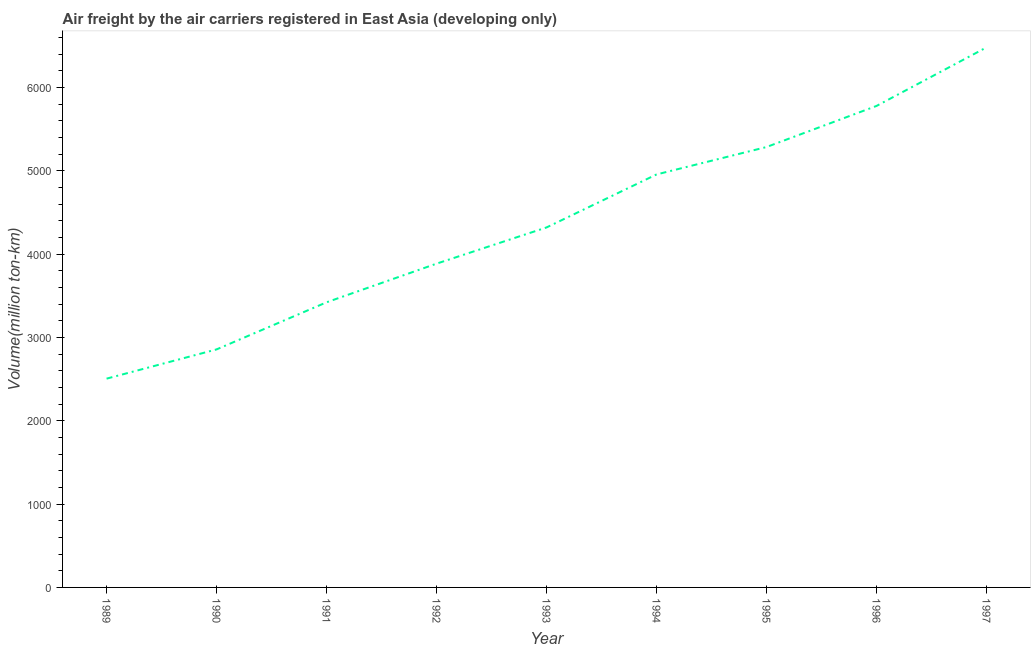What is the air freight in 1995?
Make the answer very short. 5285.2. Across all years, what is the maximum air freight?
Keep it short and to the point. 6480.9. Across all years, what is the minimum air freight?
Offer a very short reply. 2505.5. In which year was the air freight maximum?
Give a very brief answer. 1997. What is the sum of the air freight?
Keep it short and to the point. 3.95e+04. What is the difference between the air freight in 1989 and 1995?
Your answer should be compact. -2779.7. What is the average air freight per year?
Offer a very short reply. 4387.73. What is the median air freight?
Your response must be concise. 4320. Do a majority of the years between 1993 and 1992 (inclusive) have air freight greater than 800 million ton-km?
Provide a succinct answer. No. What is the ratio of the air freight in 1991 to that in 1997?
Your response must be concise. 0.53. Is the air freight in 1989 less than that in 1993?
Ensure brevity in your answer.  Yes. What is the difference between the highest and the second highest air freight?
Provide a short and direct response. 702.7. Is the sum of the air freight in 1990 and 1993 greater than the maximum air freight across all years?
Provide a succinct answer. Yes. What is the difference between the highest and the lowest air freight?
Your answer should be compact. 3975.4. In how many years, is the air freight greater than the average air freight taken over all years?
Your answer should be compact. 4. How many years are there in the graph?
Offer a terse response. 9. What is the difference between two consecutive major ticks on the Y-axis?
Your answer should be compact. 1000. Does the graph contain any zero values?
Keep it short and to the point. No. What is the title of the graph?
Your response must be concise. Air freight by the air carriers registered in East Asia (developing only). What is the label or title of the Y-axis?
Ensure brevity in your answer.  Volume(million ton-km). What is the Volume(million ton-km) of 1989?
Keep it short and to the point. 2505.5. What is the Volume(million ton-km) of 1990?
Make the answer very short. 2856.4. What is the Volume(million ton-km) of 1991?
Make the answer very short. 3421.8. What is the Volume(million ton-km) of 1992?
Give a very brief answer. 3885.5. What is the Volume(million ton-km) in 1993?
Offer a terse response. 4320. What is the Volume(million ton-km) of 1994?
Offer a very short reply. 4956.1. What is the Volume(million ton-km) in 1995?
Give a very brief answer. 5285.2. What is the Volume(million ton-km) in 1996?
Give a very brief answer. 5778.2. What is the Volume(million ton-km) of 1997?
Keep it short and to the point. 6480.9. What is the difference between the Volume(million ton-km) in 1989 and 1990?
Keep it short and to the point. -350.9. What is the difference between the Volume(million ton-km) in 1989 and 1991?
Give a very brief answer. -916.3. What is the difference between the Volume(million ton-km) in 1989 and 1992?
Provide a short and direct response. -1380. What is the difference between the Volume(million ton-km) in 1989 and 1993?
Provide a succinct answer. -1814.5. What is the difference between the Volume(million ton-km) in 1989 and 1994?
Give a very brief answer. -2450.6. What is the difference between the Volume(million ton-km) in 1989 and 1995?
Your answer should be very brief. -2779.7. What is the difference between the Volume(million ton-km) in 1989 and 1996?
Make the answer very short. -3272.7. What is the difference between the Volume(million ton-km) in 1989 and 1997?
Provide a short and direct response. -3975.4. What is the difference between the Volume(million ton-km) in 1990 and 1991?
Offer a terse response. -565.4. What is the difference between the Volume(million ton-km) in 1990 and 1992?
Offer a terse response. -1029.1. What is the difference between the Volume(million ton-km) in 1990 and 1993?
Your answer should be compact. -1463.6. What is the difference between the Volume(million ton-km) in 1990 and 1994?
Provide a short and direct response. -2099.7. What is the difference between the Volume(million ton-km) in 1990 and 1995?
Ensure brevity in your answer.  -2428.8. What is the difference between the Volume(million ton-km) in 1990 and 1996?
Keep it short and to the point. -2921.8. What is the difference between the Volume(million ton-km) in 1990 and 1997?
Your answer should be very brief. -3624.5. What is the difference between the Volume(million ton-km) in 1991 and 1992?
Give a very brief answer. -463.7. What is the difference between the Volume(million ton-km) in 1991 and 1993?
Your response must be concise. -898.2. What is the difference between the Volume(million ton-km) in 1991 and 1994?
Your answer should be very brief. -1534.3. What is the difference between the Volume(million ton-km) in 1991 and 1995?
Your answer should be compact. -1863.4. What is the difference between the Volume(million ton-km) in 1991 and 1996?
Give a very brief answer. -2356.4. What is the difference between the Volume(million ton-km) in 1991 and 1997?
Your answer should be compact. -3059.1. What is the difference between the Volume(million ton-km) in 1992 and 1993?
Your answer should be compact. -434.5. What is the difference between the Volume(million ton-km) in 1992 and 1994?
Your answer should be compact. -1070.6. What is the difference between the Volume(million ton-km) in 1992 and 1995?
Ensure brevity in your answer.  -1399.7. What is the difference between the Volume(million ton-km) in 1992 and 1996?
Keep it short and to the point. -1892.7. What is the difference between the Volume(million ton-km) in 1992 and 1997?
Ensure brevity in your answer.  -2595.4. What is the difference between the Volume(million ton-km) in 1993 and 1994?
Provide a succinct answer. -636.1. What is the difference between the Volume(million ton-km) in 1993 and 1995?
Your answer should be compact. -965.2. What is the difference between the Volume(million ton-km) in 1993 and 1996?
Provide a short and direct response. -1458.2. What is the difference between the Volume(million ton-km) in 1993 and 1997?
Give a very brief answer. -2160.9. What is the difference between the Volume(million ton-km) in 1994 and 1995?
Provide a succinct answer. -329.1. What is the difference between the Volume(million ton-km) in 1994 and 1996?
Keep it short and to the point. -822.1. What is the difference between the Volume(million ton-km) in 1994 and 1997?
Offer a terse response. -1524.8. What is the difference between the Volume(million ton-km) in 1995 and 1996?
Provide a short and direct response. -493. What is the difference between the Volume(million ton-km) in 1995 and 1997?
Your answer should be very brief. -1195.7. What is the difference between the Volume(million ton-km) in 1996 and 1997?
Offer a terse response. -702.7. What is the ratio of the Volume(million ton-km) in 1989 to that in 1990?
Offer a very short reply. 0.88. What is the ratio of the Volume(million ton-km) in 1989 to that in 1991?
Your response must be concise. 0.73. What is the ratio of the Volume(million ton-km) in 1989 to that in 1992?
Make the answer very short. 0.65. What is the ratio of the Volume(million ton-km) in 1989 to that in 1993?
Your answer should be compact. 0.58. What is the ratio of the Volume(million ton-km) in 1989 to that in 1994?
Ensure brevity in your answer.  0.51. What is the ratio of the Volume(million ton-km) in 1989 to that in 1995?
Provide a succinct answer. 0.47. What is the ratio of the Volume(million ton-km) in 1989 to that in 1996?
Make the answer very short. 0.43. What is the ratio of the Volume(million ton-km) in 1989 to that in 1997?
Ensure brevity in your answer.  0.39. What is the ratio of the Volume(million ton-km) in 1990 to that in 1991?
Your answer should be compact. 0.83. What is the ratio of the Volume(million ton-km) in 1990 to that in 1992?
Give a very brief answer. 0.73. What is the ratio of the Volume(million ton-km) in 1990 to that in 1993?
Keep it short and to the point. 0.66. What is the ratio of the Volume(million ton-km) in 1990 to that in 1994?
Your answer should be very brief. 0.58. What is the ratio of the Volume(million ton-km) in 1990 to that in 1995?
Keep it short and to the point. 0.54. What is the ratio of the Volume(million ton-km) in 1990 to that in 1996?
Your answer should be compact. 0.49. What is the ratio of the Volume(million ton-km) in 1990 to that in 1997?
Keep it short and to the point. 0.44. What is the ratio of the Volume(million ton-km) in 1991 to that in 1992?
Keep it short and to the point. 0.88. What is the ratio of the Volume(million ton-km) in 1991 to that in 1993?
Keep it short and to the point. 0.79. What is the ratio of the Volume(million ton-km) in 1991 to that in 1994?
Make the answer very short. 0.69. What is the ratio of the Volume(million ton-km) in 1991 to that in 1995?
Offer a very short reply. 0.65. What is the ratio of the Volume(million ton-km) in 1991 to that in 1996?
Provide a succinct answer. 0.59. What is the ratio of the Volume(million ton-km) in 1991 to that in 1997?
Make the answer very short. 0.53. What is the ratio of the Volume(million ton-km) in 1992 to that in 1993?
Your answer should be compact. 0.9. What is the ratio of the Volume(million ton-km) in 1992 to that in 1994?
Offer a terse response. 0.78. What is the ratio of the Volume(million ton-km) in 1992 to that in 1995?
Ensure brevity in your answer.  0.73. What is the ratio of the Volume(million ton-km) in 1992 to that in 1996?
Offer a terse response. 0.67. What is the ratio of the Volume(million ton-km) in 1993 to that in 1994?
Give a very brief answer. 0.87. What is the ratio of the Volume(million ton-km) in 1993 to that in 1995?
Make the answer very short. 0.82. What is the ratio of the Volume(million ton-km) in 1993 to that in 1996?
Offer a very short reply. 0.75. What is the ratio of the Volume(million ton-km) in 1993 to that in 1997?
Provide a short and direct response. 0.67. What is the ratio of the Volume(million ton-km) in 1994 to that in 1995?
Your answer should be very brief. 0.94. What is the ratio of the Volume(million ton-km) in 1994 to that in 1996?
Keep it short and to the point. 0.86. What is the ratio of the Volume(million ton-km) in 1994 to that in 1997?
Provide a short and direct response. 0.77. What is the ratio of the Volume(million ton-km) in 1995 to that in 1996?
Give a very brief answer. 0.92. What is the ratio of the Volume(million ton-km) in 1995 to that in 1997?
Offer a terse response. 0.82. What is the ratio of the Volume(million ton-km) in 1996 to that in 1997?
Provide a succinct answer. 0.89. 